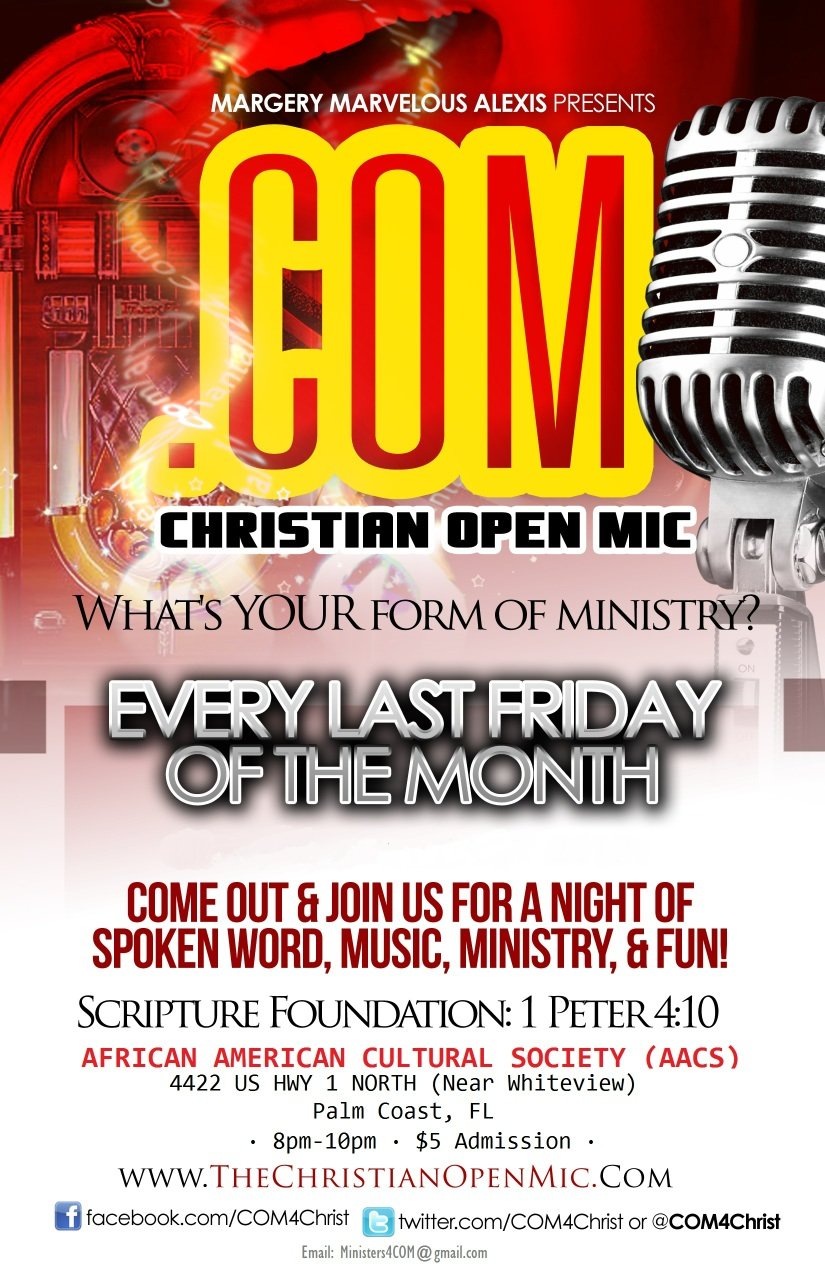What logistical details are provided for attending the event? The Christian Open Mic event is held every last Friday of the month from 8:00 PM to 10:00 PM at the African American Cultural Society located at 4422 US HWY 1 North, near Whiteview, in Palm Coast, FL. There is a $5 admission fee for attendees. More information can be found on their website, www.TheChristianOpenMic.com, or by following their social media profiles on Facebook, Twitter, and Instagram at COM4Christ. 